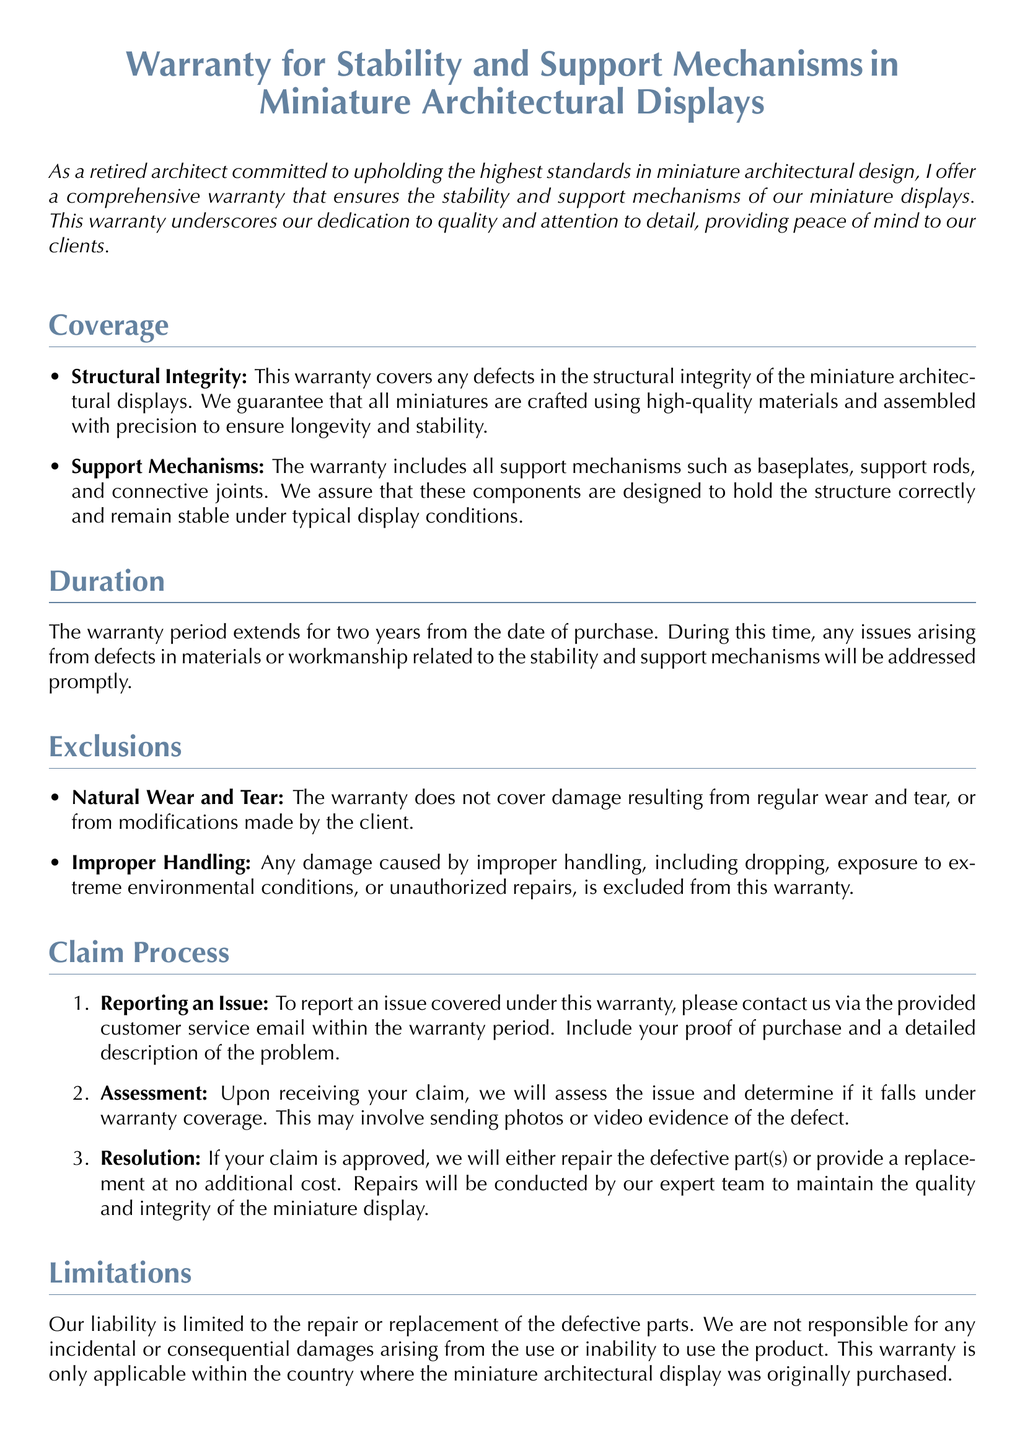What is covered under the warranty? The warranty covers structural integrity and support mechanisms of the miniature displays.
Answer: Structural Integrity, Support Mechanisms What is the duration of the warranty? The duration of the warranty is specifically stated in the document, which is for two years from the date of purchase.
Answer: Two years What types of damage are excluded from the warranty? The document lists exclusions, including natural wear and tear, and improper handling.
Answer: Natural Wear and Tear, Improper Handling What is the first step in the claim process? The first step in the claim process involves reporting an issue to customer service within the warranty period.
Answer: Reporting an Issue What will happen if a claim is approved? If a claim is approved, the process entails repairing defective parts or providing a replacement at no additional cost.
Answer: Repair or Replacement What is the customer service email provided for warranty issues? The document provides a specific email for customer service inquiries regarding warranty claims.
Answer: warranty@archminiatures.com What materials are guaranteed for quality under the warranty? The warranty guarantees high-quality materials used in crafting the miniature architectural displays.
Answer: High-quality materials What is the address for customer service? The document specifies a physical location for customer service inquiries related to the warranty.
Answer: 123 Miniature Lane, Model Town, State, ZIP Code 